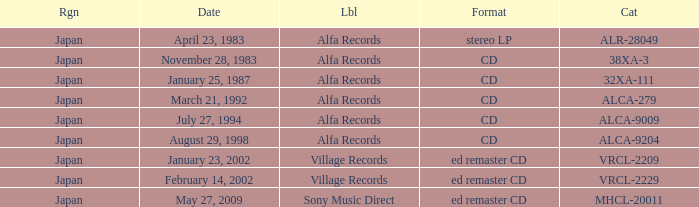Would you be able to parse every entry in this table? {'header': ['Rgn', 'Date', 'Lbl', 'Format', 'Cat'], 'rows': [['Japan', 'April 23, 1983', 'Alfa Records', 'stereo LP', 'ALR-28049'], ['Japan', 'November 28, 1983', 'Alfa Records', 'CD', '38XA-3'], ['Japan', 'January 25, 1987', 'Alfa Records', 'CD', '32XA-111'], ['Japan', 'March 21, 1992', 'Alfa Records', 'CD', 'ALCA-279'], ['Japan', 'July 27, 1994', 'Alfa Records', 'CD', 'ALCA-9009'], ['Japan', 'August 29, 1998', 'Alfa Records', 'CD', 'ALCA-9204'], ['Japan', 'January 23, 2002', 'Village Records', 'ed remaster CD', 'VRCL-2209'], ['Japan', 'February 14, 2002', 'Village Records', 'ed remaster CD', 'VRCL-2229'], ['Japan', 'May 27, 2009', 'Sony Music Direct', 'ed remaster CD', 'MHCL-20011']]} Which date is in CD format? November 28, 1983, January 25, 1987, March 21, 1992, July 27, 1994, August 29, 1998. 